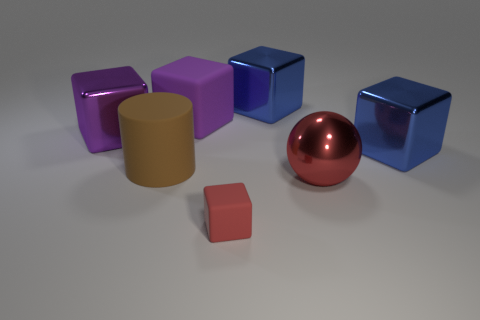Subtract 2 blocks. How many blocks are left? 3 Subtract all red blocks. How many blocks are left? 4 Add 1 purple metallic cylinders. How many objects exist? 8 Subtract all red rubber blocks. How many blocks are left? 4 Subtract all green blocks. Subtract all gray spheres. How many blocks are left? 5 Subtract all spheres. How many objects are left? 6 Add 5 brown objects. How many brown objects exist? 6 Subtract 0 gray cubes. How many objects are left? 7 Subtract all tiny purple balls. Subtract all big purple cubes. How many objects are left? 5 Add 7 shiny blocks. How many shiny blocks are left? 10 